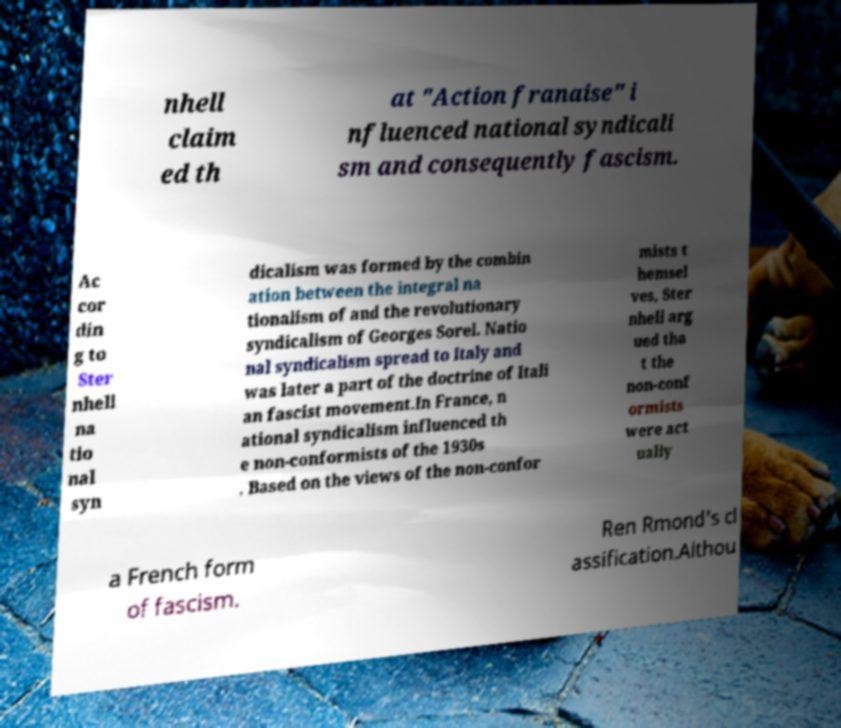Could you assist in decoding the text presented in this image and type it out clearly? nhell claim ed th at "Action franaise" i nfluenced national syndicali sm and consequently fascism. Ac cor din g to Ster nhell na tio nal syn dicalism was formed by the combin ation between the integral na tionalism of and the revolutionary syndicalism of Georges Sorel. Natio nal syndicalism spread to Italy and was later a part of the doctrine of Itali an fascist movement.In France, n ational syndicalism influenced th e non-conformists of the 1930s . Based on the views of the non-confor mists t hemsel ves, Ster nhell arg ued tha t the non-conf ormists were act ually a French form of fascism. Ren Rmond's cl assification.Althou 